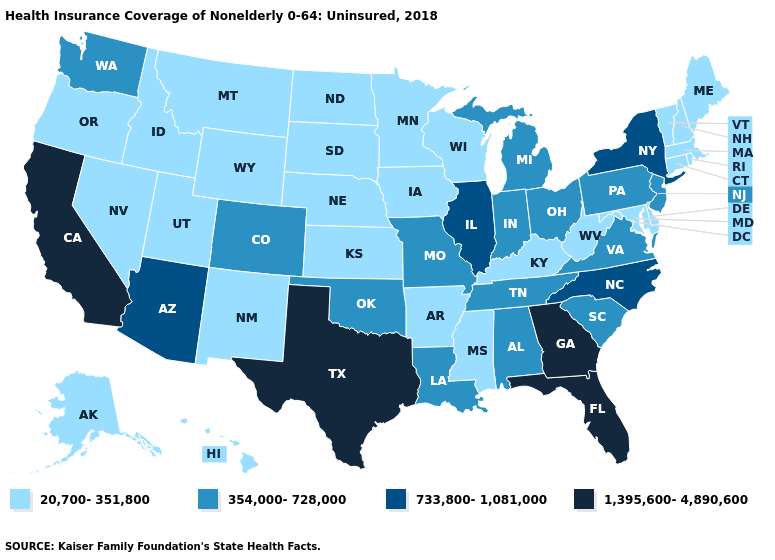Does Georgia have the lowest value in the USA?
Concise answer only. No. What is the value of Iowa?
Quick response, please. 20,700-351,800. What is the highest value in states that border Florida?
Concise answer only. 1,395,600-4,890,600. Name the states that have a value in the range 1,395,600-4,890,600?
Quick response, please. California, Florida, Georgia, Texas. Does the map have missing data?
Concise answer only. No. Among the states that border West Virginia , does Virginia have the lowest value?
Be succinct. No. Among the states that border Indiana , does Michigan have the lowest value?
Be succinct. No. Does Montana have the highest value in the USA?
Give a very brief answer. No. What is the lowest value in the USA?
Short answer required. 20,700-351,800. Name the states that have a value in the range 733,800-1,081,000?
Give a very brief answer. Arizona, Illinois, New York, North Carolina. What is the value of Massachusetts?
Concise answer only. 20,700-351,800. Does Pennsylvania have a higher value than Mississippi?
Answer briefly. Yes. Is the legend a continuous bar?
Be succinct. No. Does the map have missing data?
Give a very brief answer. No. Which states have the lowest value in the West?
Answer briefly. Alaska, Hawaii, Idaho, Montana, Nevada, New Mexico, Oregon, Utah, Wyoming. 